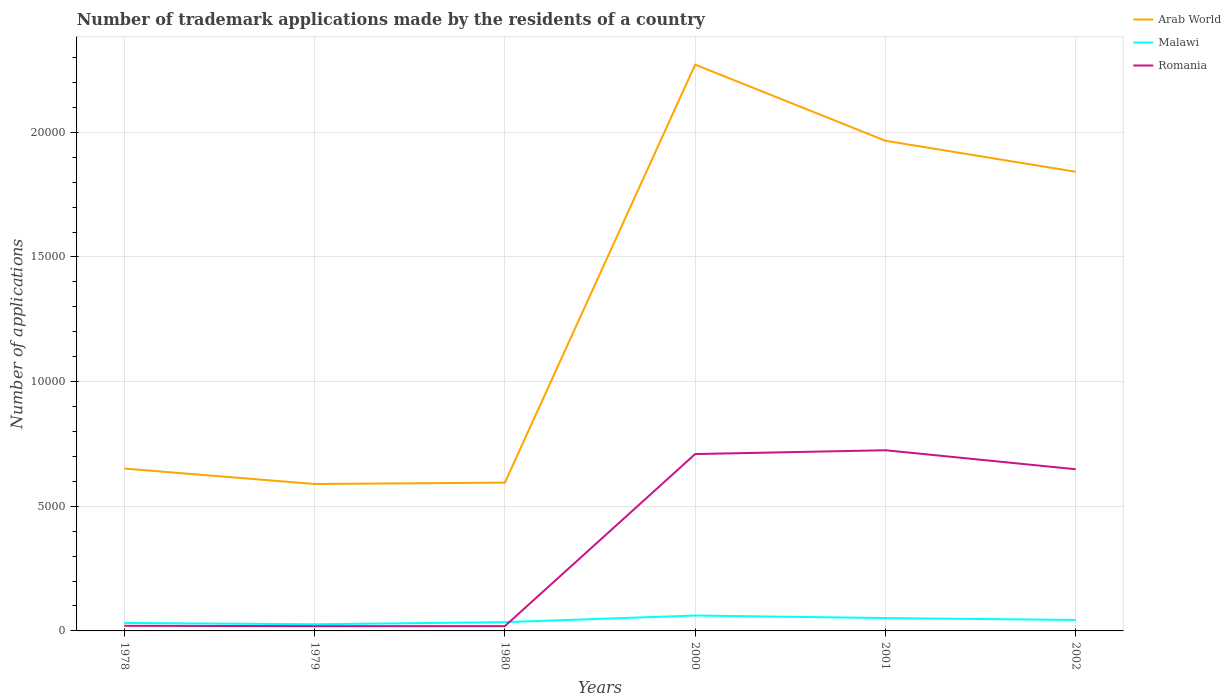Across all years, what is the maximum number of trademark applications made by the residents in Romania?
Make the answer very short. 191. In which year was the number of trademark applications made by the residents in Romania maximum?
Keep it short and to the point. 1979. What is the total number of trademark applications made by the residents in Romania in the graph?
Give a very brief answer. -7055. What is the difference between the highest and the second highest number of trademark applications made by the residents in Malawi?
Your response must be concise. 351. Is the number of trademark applications made by the residents in Malawi strictly greater than the number of trademark applications made by the residents in Arab World over the years?
Your answer should be very brief. Yes. How many years are there in the graph?
Offer a terse response. 6. Are the values on the major ticks of Y-axis written in scientific E-notation?
Provide a succinct answer. No. Does the graph contain grids?
Offer a very short reply. Yes. How many legend labels are there?
Make the answer very short. 3. What is the title of the graph?
Your answer should be compact. Number of trademark applications made by the residents of a country. What is the label or title of the X-axis?
Your answer should be very brief. Years. What is the label or title of the Y-axis?
Make the answer very short. Number of applications. What is the Number of applications of Arab World in 1978?
Provide a short and direct response. 6512. What is the Number of applications in Malawi in 1978?
Provide a short and direct response. 320. What is the Number of applications of Romania in 1978?
Your answer should be very brief. 205. What is the Number of applications in Arab World in 1979?
Your answer should be very brief. 5893. What is the Number of applications in Malawi in 1979?
Your answer should be compact. 267. What is the Number of applications in Romania in 1979?
Make the answer very short. 191. What is the Number of applications in Arab World in 1980?
Keep it short and to the point. 5948. What is the Number of applications of Malawi in 1980?
Ensure brevity in your answer.  351. What is the Number of applications in Romania in 1980?
Offer a very short reply. 192. What is the Number of applications in Arab World in 2000?
Your response must be concise. 2.27e+04. What is the Number of applications of Malawi in 2000?
Provide a short and direct response. 618. What is the Number of applications in Romania in 2000?
Offer a terse response. 7094. What is the Number of applications of Arab World in 2001?
Your response must be concise. 1.97e+04. What is the Number of applications in Malawi in 2001?
Provide a succinct answer. 515. What is the Number of applications in Romania in 2001?
Provide a short and direct response. 7247. What is the Number of applications of Arab World in 2002?
Ensure brevity in your answer.  1.84e+04. What is the Number of applications in Malawi in 2002?
Your answer should be very brief. 440. What is the Number of applications in Romania in 2002?
Provide a succinct answer. 6485. Across all years, what is the maximum Number of applications in Arab World?
Provide a short and direct response. 2.27e+04. Across all years, what is the maximum Number of applications of Malawi?
Provide a succinct answer. 618. Across all years, what is the maximum Number of applications in Romania?
Your response must be concise. 7247. Across all years, what is the minimum Number of applications of Arab World?
Make the answer very short. 5893. Across all years, what is the minimum Number of applications of Malawi?
Ensure brevity in your answer.  267. Across all years, what is the minimum Number of applications in Romania?
Make the answer very short. 191. What is the total Number of applications in Arab World in the graph?
Ensure brevity in your answer.  7.91e+04. What is the total Number of applications of Malawi in the graph?
Make the answer very short. 2511. What is the total Number of applications in Romania in the graph?
Give a very brief answer. 2.14e+04. What is the difference between the Number of applications of Arab World in 1978 and that in 1979?
Provide a succinct answer. 619. What is the difference between the Number of applications of Arab World in 1978 and that in 1980?
Your response must be concise. 564. What is the difference between the Number of applications of Malawi in 1978 and that in 1980?
Give a very brief answer. -31. What is the difference between the Number of applications in Arab World in 1978 and that in 2000?
Give a very brief answer. -1.62e+04. What is the difference between the Number of applications of Malawi in 1978 and that in 2000?
Offer a very short reply. -298. What is the difference between the Number of applications in Romania in 1978 and that in 2000?
Make the answer very short. -6889. What is the difference between the Number of applications of Arab World in 1978 and that in 2001?
Keep it short and to the point. -1.31e+04. What is the difference between the Number of applications in Malawi in 1978 and that in 2001?
Offer a very short reply. -195. What is the difference between the Number of applications in Romania in 1978 and that in 2001?
Offer a terse response. -7042. What is the difference between the Number of applications of Arab World in 1978 and that in 2002?
Your response must be concise. -1.19e+04. What is the difference between the Number of applications in Malawi in 1978 and that in 2002?
Provide a short and direct response. -120. What is the difference between the Number of applications of Romania in 1978 and that in 2002?
Your response must be concise. -6280. What is the difference between the Number of applications of Arab World in 1979 and that in 1980?
Your response must be concise. -55. What is the difference between the Number of applications in Malawi in 1979 and that in 1980?
Provide a short and direct response. -84. What is the difference between the Number of applications of Arab World in 1979 and that in 2000?
Offer a very short reply. -1.68e+04. What is the difference between the Number of applications in Malawi in 1979 and that in 2000?
Give a very brief answer. -351. What is the difference between the Number of applications of Romania in 1979 and that in 2000?
Provide a succinct answer. -6903. What is the difference between the Number of applications of Arab World in 1979 and that in 2001?
Your answer should be compact. -1.38e+04. What is the difference between the Number of applications in Malawi in 1979 and that in 2001?
Make the answer very short. -248. What is the difference between the Number of applications of Romania in 1979 and that in 2001?
Offer a terse response. -7056. What is the difference between the Number of applications in Arab World in 1979 and that in 2002?
Offer a very short reply. -1.25e+04. What is the difference between the Number of applications in Malawi in 1979 and that in 2002?
Ensure brevity in your answer.  -173. What is the difference between the Number of applications of Romania in 1979 and that in 2002?
Keep it short and to the point. -6294. What is the difference between the Number of applications of Arab World in 1980 and that in 2000?
Provide a short and direct response. -1.68e+04. What is the difference between the Number of applications in Malawi in 1980 and that in 2000?
Your answer should be compact. -267. What is the difference between the Number of applications of Romania in 1980 and that in 2000?
Your response must be concise. -6902. What is the difference between the Number of applications of Arab World in 1980 and that in 2001?
Keep it short and to the point. -1.37e+04. What is the difference between the Number of applications in Malawi in 1980 and that in 2001?
Offer a terse response. -164. What is the difference between the Number of applications of Romania in 1980 and that in 2001?
Provide a succinct answer. -7055. What is the difference between the Number of applications of Arab World in 1980 and that in 2002?
Your response must be concise. -1.25e+04. What is the difference between the Number of applications of Malawi in 1980 and that in 2002?
Offer a very short reply. -89. What is the difference between the Number of applications in Romania in 1980 and that in 2002?
Give a very brief answer. -6293. What is the difference between the Number of applications in Arab World in 2000 and that in 2001?
Keep it short and to the point. 3053. What is the difference between the Number of applications of Malawi in 2000 and that in 2001?
Offer a very short reply. 103. What is the difference between the Number of applications of Romania in 2000 and that in 2001?
Give a very brief answer. -153. What is the difference between the Number of applications in Arab World in 2000 and that in 2002?
Your response must be concise. 4296. What is the difference between the Number of applications of Malawi in 2000 and that in 2002?
Ensure brevity in your answer.  178. What is the difference between the Number of applications of Romania in 2000 and that in 2002?
Offer a terse response. 609. What is the difference between the Number of applications in Arab World in 2001 and that in 2002?
Give a very brief answer. 1243. What is the difference between the Number of applications of Malawi in 2001 and that in 2002?
Your response must be concise. 75. What is the difference between the Number of applications in Romania in 2001 and that in 2002?
Your answer should be very brief. 762. What is the difference between the Number of applications in Arab World in 1978 and the Number of applications in Malawi in 1979?
Offer a terse response. 6245. What is the difference between the Number of applications of Arab World in 1978 and the Number of applications of Romania in 1979?
Make the answer very short. 6321. What is the difference between the Number of applications of Malawi in 1978 and the Number of applications of Romania in 1979?
Offer a very short reply. 129. What is the difference between the Number of applications of Arab World in 1978 and the Number of applications of Malawi in 1980?
Offer a terse response. 6161. What is the difference between the Number of applications in Arab World in 1978 and the Number of applications in Romania in 1980?
Offer a very short reply. 6320. What is the difference between the Number of applications of Malawi in 1978 and the Number of applications of Romania in 1980?
Provide a succinct answer. 128. What is the difference between the Number of applications in Arab World in 1978 and the Number of applications in Malawi in 2000?
Ensure brevity in your answer.  5894. What is the difference between the Number of applications in Arab World in 1978 and the Number of applications in Romania in 2000?
Provide a succinct answer. -582. What is the difference between the Number of applications of Malawi in 1978 and the Number of applications of Romania in 2000?
Ensure brevity in your answer.  -6774. What is the difference between the Number of applications in Arab World in 1978 and the Number of applications in Malawi in 2001?
Make the answer very short. 5997. What is the difference between the Number of applications in Arab World in 1978 and the Number of applications in Romania in 2001?
Provide a short and direct response. -735. What is the difference between the Number of applications of Malawi in 1978 and the Number of applications of Romania in 2001?
Provide a succinct answer. -6927. What is the difference between the Number of applications in Arab World in 1978 and the Number of applications in Malawi in 2002?
Offer a very short reply. 6072. What is the difference between the Number of applications of Arab World in 1978 and the Number of applications of Romania in 2002?
Provide a short and direct response. 27. What is the difference between the Number of applications in Malawi in 1978 and the Number of applications in Romania in 2002?
Provide a succinct answer. -6165. What is the difference between the Number of applications in Arab World in 1979 and the Number of applications in Malawi in 1980?
Your answer should be very brief. 5542. What is the difference between the Number of applications of Arab World in 1979 and the Number of applications of Romania in 1980?
Give a very brief answer. 5701. What is the difference between the Number of applications of Arab World in 1979 and the Number of applications of Malawi in 2000?
Provide a short and direct response. 5275. What is the difference between the Number of applications of Arab World in 1979 and the Number of applications of Romania in 2000?
Your answer should be compact. -1201. What is the difference between the Number of applications of Malawi in 1979 and the Number of applications of Romania in 2000?
Provide a short and direct response. -6827. What is the difference between the Number of applications in Arab World in 1979 and the Number of applications in Malawi in 2001?
Make the answer very short. 5378. What is the difference between the Number of applications in Arab World in 1979 and the Number of applications in Romania in 2001?
Make the answer very short. -1354. What is the difference between the Number of applications of Malawi in 1979 and the Number of applications of Romania in 2001?
Offer a terse response. -6980. What is the difference between the Number of applications of Arab World in 1979 and the Number of applications of Malawi in 2002?
Your answer should be compact. 5453. What is the difference between the Number of applications of Arab World in 1979 and the Number of applications of Romania in 2002?
Your answer should be very brief. -592. What is the difference between the Number of applications of Malawi in 1979 and the Number of applications of Romania in 2002?
Provide a succinct answer. -6218. What is the difference between the Number of applications in Arab World in 1980 and the Number of applications in Malawi in 2000?
Provide a succinct answer. 5330. What is the difference between the Number of applications of Arab World in 1980 and the Number of applications of Romania in 2000?
Ensure brevity in your answer.  -1146. What is the difference between the Number of applications of Malawi in 1980 and the Number of applications of Romania in 2000?
Give a very brief answer. -6743. What is the difference between the Number of applications of Arab World in 1980 and the Number of applications of Malawi in 2001?
Your answer should be compact. 5433. What is the difference between the Number of applications in Arab World in 1980 and the Number of applications in Romania in 2001?
Ensure brevity in your answer.  -1299. What is the difference between the Number of applications in Malawi in 1980 and the Number of applications in Romania in 2001?
Provide a short and direct response. -6896. What is the difference between the Number of applications of Arab World in 1980 and the Number of applications of Malawi in 2002?
Your response must be concise. 5508. What is the difference between the Number of applications of Arab World in 1980 and the Number of applications of Romania in 2002?
Give a very brief answer. -537. What is the difference between the Number of applications in Malawi in 1980 and the Number of applications in Romania in 2002?
Offer a very short reply. -6134. What is the difference between the Number of applications in Arab World in 2000 and the Number of applications in Malawi in 2001?
Your response must be concise. 2.22e+04. What is the difference between the Number of applications in Arab World in 2000 and the Number of applications in Romania in 2001?
Provide a short and direct response. 1.55e+04. What is the difference between the Number of applications in Malawi in 2000 and the Number of applications in Romania in 2001?
Provide a short and direct response. -6629. What is the difference between the Number of applications of Arab World in 2000 and the Number of applications of Malawi in 2002?
Provide a short and direct response. 2.23e+04. What is the difference between the Number of applications of Arab World in 2000 and the Number of applications of Romania in 2002?
Your answer should be compact. 1.62e+04. What is the difference between the Number of applications in Malawi in 2000 and the Number of applications in Romania in 2002?
Offer a terse response. -5867. What is the difference between the Number of applications in Arab World in 2001 and the Number of applications in Malawi in 2002?
Your response must be concise. 1.92e+04. What is the difference between the Number of applications of Arab World in 2001 and the Number of applications of Romania in 2002?
Offer a terse response. 1.32e+04. What is the difference between the Number of applications of Malawi in 2001 and the Number of applications of Romania in 2002?
Ensure brevity in your answer.  -5970. What is the average Number of applications in Arab World per year?
Offer a terse response. 1.32e+04. What is the average Number of applications of Malawi per year?
Your response must be concise. 418.5. What is the average Number of applications of Romania per year?
Give a very brief answer. 3569. In the year 1978, what is the difference between the Number of applications of Arab World and Number of applications of Malawi?
Give a very brief answer. 6192. In the year 1978, what is the difference between the Number of applications in Arab World and Number of applications in Romania?
Make the answer very short. 6307. In the year 1978, what is the difference between the Number of applications of Malawi and Number of applications of Romania?
Offer a very short reply. 115. In the year 1979, what is the difference between the Number of applications of Arab World and Number of applications of Malawi?
Provide a short and direct response. 5626. In the year 1979, what is the difference between the Number of applications in Arab World and Number of applications in Romania?
Your answer should be compact. 5702. In the year 1980, what is the difference between the Number of applications in Arab World and Number of applications in Malawi?
Make the answer very short. 5597. In the year 1980, what is the difference between the Number of applications of Arab World and Number of applications of Romania?
Offer a very short reply. 5756. In the year 1980, what is the difference between the Number of applications in Malawi and Number of applications in Romania?
Keep it short and to the point. 159. In the year 2000, what is the difference between the Number of applications of Arab World and Number of applications of Malawi?
Give a very brief answer. 2.21e+04. In the year 2000, what is the difference between the Number of applications of Arab World and Number of applications of Romania?
Keep it short and to the point. 1.56e+04. In the year 2000, what is the difference between the Number of applications in Malawi and Number of applications in Romania?
Provide a short and direct response. -6476. In the year 2001, what is the difference between the Number of applications of Arab World and Number of applications of Malawi?
Offer a very short reply. 1.91e+04. In the year 2001, what is the difference between the Number of applications of Arab World and Number of applications of Romania?
Your answer should be very brief. 1.24e+04. In the year 2001, what is the difference between the Number of applications in Malawi and Number of applications in Romania?
Offer a terse response. -6732. In the year 2002, what is the difference between the Number of applications in Arab World and Number of applications in Malawi?
Your response must be concise. 1.80e+04. In the year 2002, what is the difference between the Number of applications of Arab World and Number of applications of Romania?
Make the answer very short. 1.19e+04. In the year 2002, what is the difference between the Number of applications in Malawi and Number of applications in Romania?
Offer a very short reply. -6045. What is the ratio of the Number of applications of Arab World in 1978 to that in 1979?
Your answer should be very brief. 1.1. What is the ratio of the Number of applications in Malawi in 1978 to that in 1979?
Your response must be concise. 1.2. What is the ratio of the Number of applications in Romania in 1978 to that in 1979?
Provide a succinct answer. 1.07. What is the ratio of the Number of applications of Arab World in 1978 to that in 1980?
Keep it short and to the point. 1.09. What is the ratio of the Number of applications of Malawi in 1978 to that in 1980?
Provide a short and direct response. 0.91. What is the ratio of the Number of applications in Romania in 1978 to that in 1980?
Offer a very short reply. 1.07. What is the ratio of the Number of applications of Arab World in 1978 to that in 2000?
Keep it short and to the point. 0.29. What is the ratio of the Number of applications of Malawi in 1978 to that in 2000?
Make the answer very short. 0.52. What is the ratio of the Number of applications in Romania in 1978 to that in 2000?
Offer a terse response. 0.03. What is the ratio of the Number of applications of Arab World in 1978 to that in 2001?
Keep it short and to the point. 0.33. What is the ratio of the Number of applications in Malawi in 1978 to that in 2001?
Make the answer very short. 0.62. What is the ratio of the Number of applications in Romania in 1978 to that in 2001?
Your answer should be compact. 0.03. What is the ratio of the Number of applications in Arab World in 1978 to that in 2002?
Ensure brevity in your answer.  0.35. What is the ratio of the Number of applications of Malawi in 1978 to that in 2002?
Provide a succinct answer. 0.73. What is the ratio of the Number of applications of Romania in 1978 to that in 2002?
Ensure brevity in your answer.  0.03. What is the ratio of the Number of applications of Malawi in 1979 to that in 1980?
Make the answer very short. 0.76. What is the ratio of the Number of applications in Romania in 1979 to that in 1980?
Offer a terse response. 0.99. What is the ratio of the Number of applications of Arab World in 1979 to that in 2000?
Make the answer very short. 0.26. What is the ratio of the Number of applications of Malawi in 1979 to that in 2000?
Provide a short and direct response. 0.43. What is the ratio of the Number of applications in Romania in 1979 to that in 2000?
Your answer should be compact. 0.03. What is the ratio of the Number of applications in Arab World in 1979 to that in 2001?
Give a very brief answer. 0.3. What is the ratio of the Number of applications in Malawi in 1979 to that in 2001?
Make the answer very short. 0.52. What is the ratio of the Number of applications in Romania in 1979 to that in 2001?
Ensure brevity in your answer.  0.03. What is the ratio of the Number of applications of Arab World in 1979 to that in 2002?
Offer a very short reply. 0.32. What is the ratio of the Number of applications in Malawi in 1979 to that in 2002?
Ensure brevity in your answer.  0.61. What is the ratio of the Number of applications of Romania in 1979 to that in 2002?
Ensure brevity in your answer.  0.03. What is the ratio of the Number of applications of Arab World in 1980 to that in 2000?
Make the answer very short. 0.26. What is the ratio of the Number of applications in Malawi in 1980 to that in 2000?
Your response must be concise. 0.57. What is the ratio of the Number of applications in Romania in 1980 to that in 2000?
Your answer should be compact. 0.03. What is the ratio of the Number of applications of Arab World in 1980 to that in 2001?
Your answer should be very brief. 0.3. What is the ratio of the Number of applications in Malawi in 1980 to that in 2001?
Keep it short and to the point. 0.68. What is the ratio of the Number of applications of Romania in 1980 to that in 2001?
Provide a succinct answer. 0.03. What is the ratio of the Number of applications of Arab World in 1980 to that in 2002?
Ensure brevity in your answer.  0.32. What is the ratio of the Number of applications of Malawi in 1980 to that in 2002?
Your response must be concise. 0.8. What is the ratio of the Number of applications in Romania in 1980 to that in 2002?
Provide a short and direct response. 0.03. What is the ratio of the Number of applications in Arab World in 2000 to that in 2001?
Provide a succinct answer. 1.16. What is the ratio of the Number of applications in Romania in 2000 to that in 2001?
Provide a succinct answer. 0.98. What is the ratio of the Number of applications of Arab World in 2000 to that in 2002?
Give a very brief answer. 1.23. What is the ratio of the Number of applications in Malawi in 2000 to that in 2002?
Give a very brief answer. 1.4. What is the ratio of the Number of applications in Romania in 2000 to that in 2002?
Your response must be concise. 1.09. What is the ratio of the Number of applications of Arab World in 2001 to that in 2002?
Keep it short and to the point. 1.07. What is the ratio of the Number of applications in Malawi in 2001 to that in 2002?
Ensure brevity in your answer.  1.17. What is the ratio of the Number of applications in Romania in 2001 to that in 2002?
Offer a terse response. 1.12. What is the difference between the highest and the second highest Number of applications in Arab World?
Make the answer very short. 3053. What is the difference between the highest and the second highest Number of applications of Malawi?
Make the answer very short. 103. What is the difference between the highest and the second highest Number of applications of Romania?
Your answer should be very brief. 153. What is the difference between the highest and the lowest Number of applications in Arab World?
Give a very brief answer. 1.68e+04. What is the difference between the highest and the lowest Number of applications in Malawi?
Keep it short and to the point. 351. What is the difference between the highest and the lowest Number of applications in Romania?
Keep it short and to the point. 7056. 